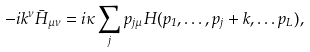Convert formula to latex. <formula><loc_0><loc_0><loc_500><loc_500>- i k ^ { \nu } \bar { H } _ { \mu \nu } = i \kappa \sum _ { j } p _ { j \mu } H ( p _ { 1 } , \dots , p _ { j } + k , \dots p _ { L } ) ,</formula> 